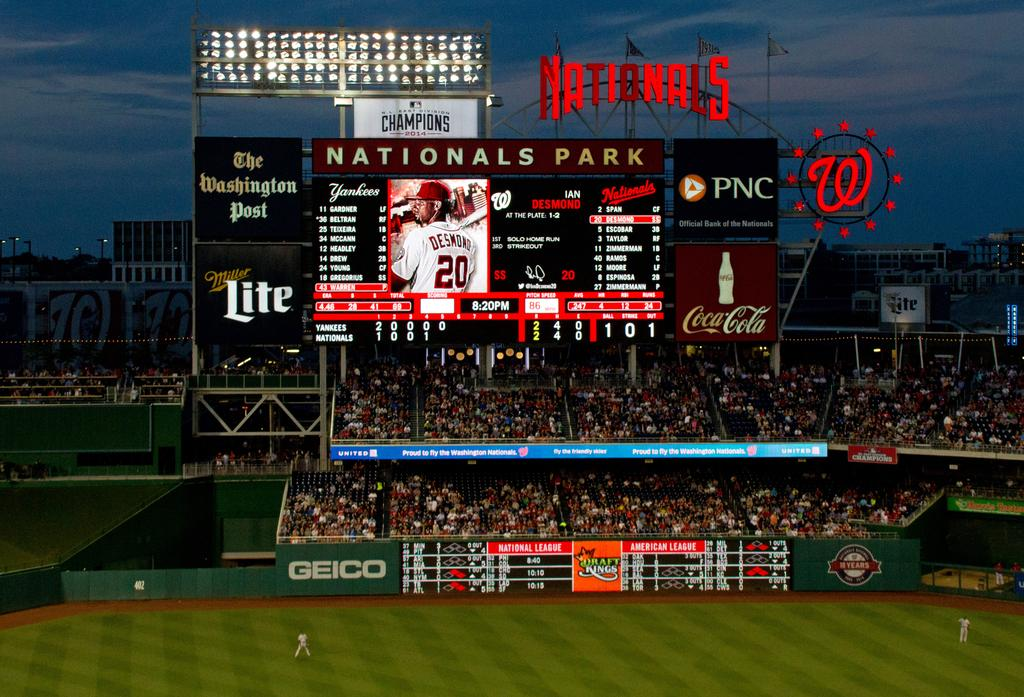<image>
Share a concise interpretation of the image provided. The scoreboard at National Park sponsored by the Washington Post, PNC, Miller Lite, and Coca Cola. 